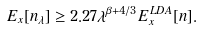<formula> <loc_0><loc_0><loc_500><loc_500>E _ { x } [ n _ { \lambda } ] \geq 2 . 2 7 \lambda ^ { \beta + 4 / 3 } E _ { x } ^ { L D A } [ n ] .</formula> 